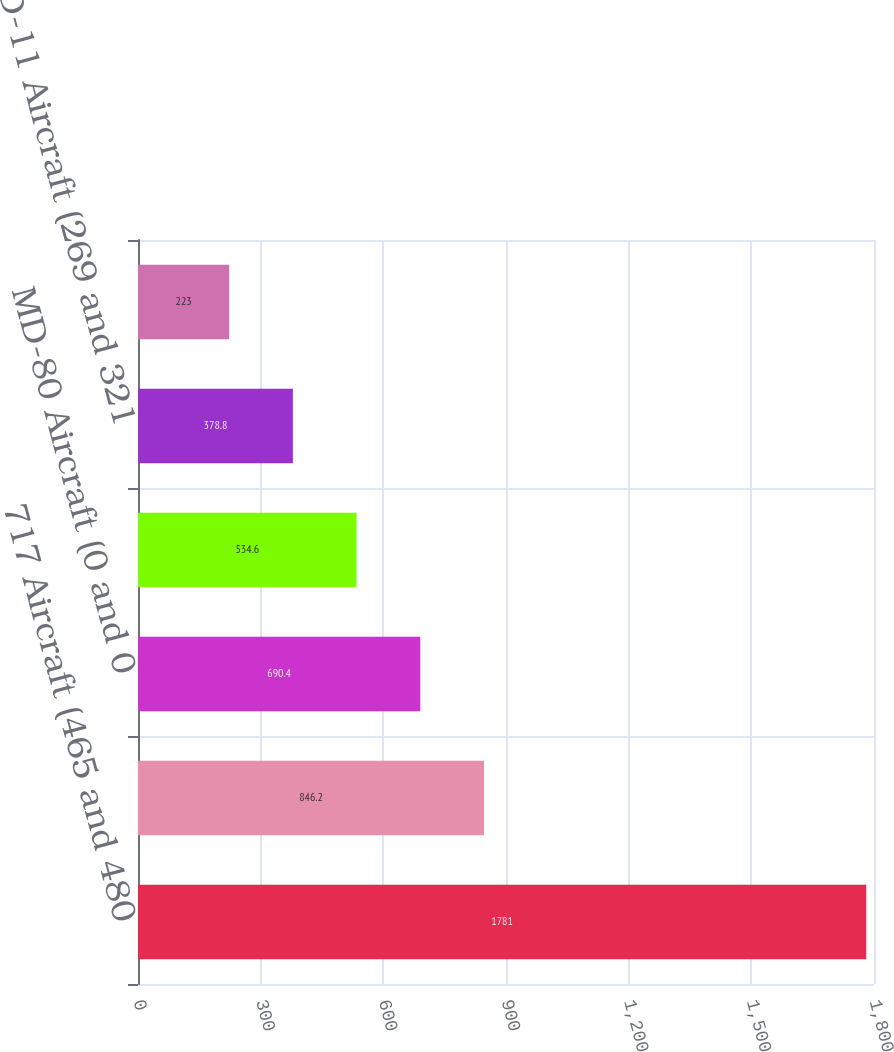Convert chart to OTSL. <chart><loc_0><loc_0><loc_500><loc_500><bar_chart><fcel>717 Aircraft (465 and 480<fcel>757 Aircraft (454 and 451<fcel>MD-80 Aircraft (0 and 0<fcel>737 Aircraft (193 and 242<fcel>MD-11 Aircraft (269 and 321<fcel>767 Aircraft (63 and 103<nl><fcel>1781<fcel>846.2<fcel>690.4<fcel>534.6<fcel>378.8<fcel>223<nl></chart> 